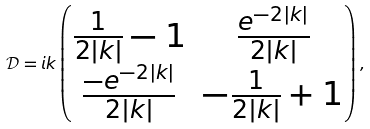<formula> <loc_0><loc_0><loc_500><loc_500>\mathcal { D } = i k \begin{pmatrix} \frac { 1 } { 2 | k | } - 1 & \frac { e ^ { - 2 | k | } } { 2 | k | } \\ \frac { - e ^ { - 2 | k | } } { 2 | k | } & - \frac { 1 } { 2 | k | } + 1 \\ \end{pmatrix} ,</formula> 